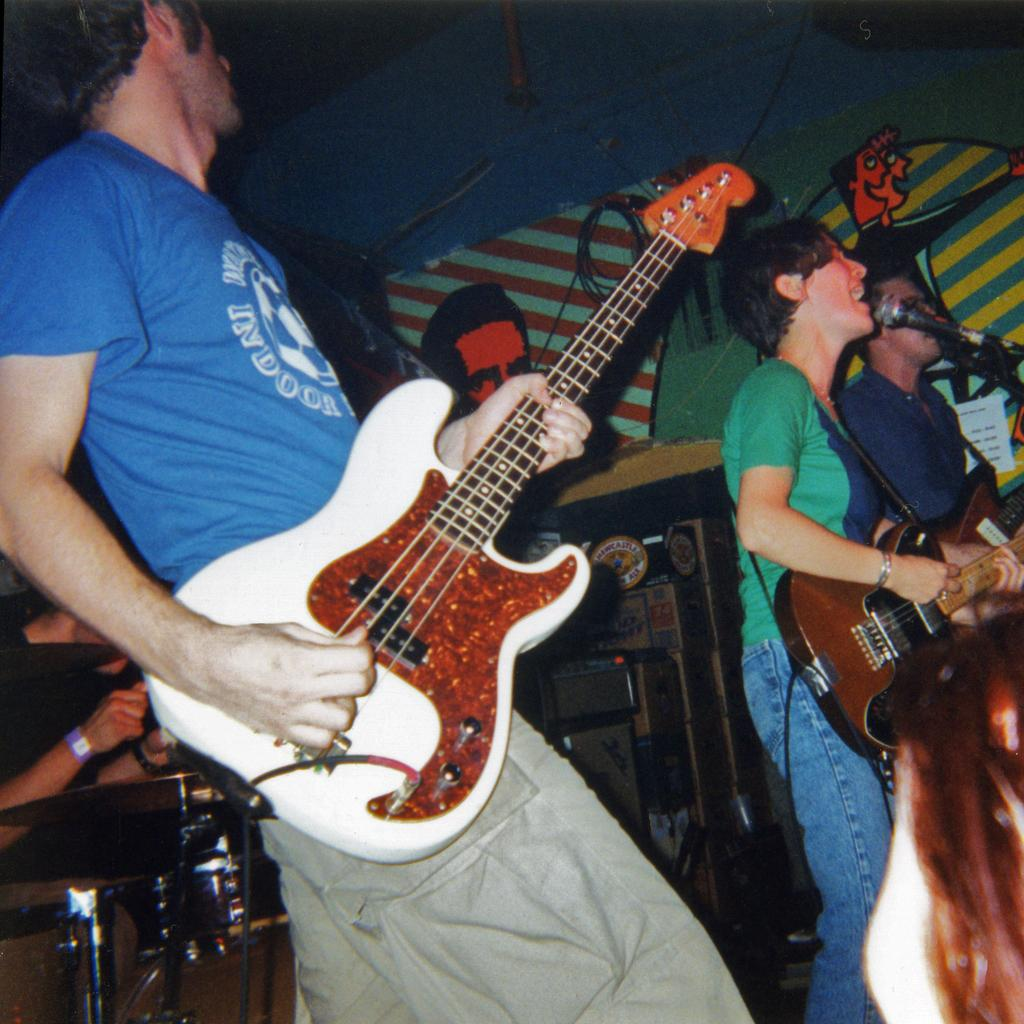How many people are in the image? There are three persons in the image. What are the persons doing in the image? The persons are standing and holding guitars. What object is in front of the persons? There is a microphone in front of the persons. What can be seen in the background of the image? There is a banner in the background of the image, and other musical instruments are visible as well. How many beans are on the guitar strings in the image? There are no beans present in the image, and the guitar strings are not related to beans. Are there any balloons visible in the image? There are no balloons visible in the image; the focus is on the persons, their guitars, and the microphone. 